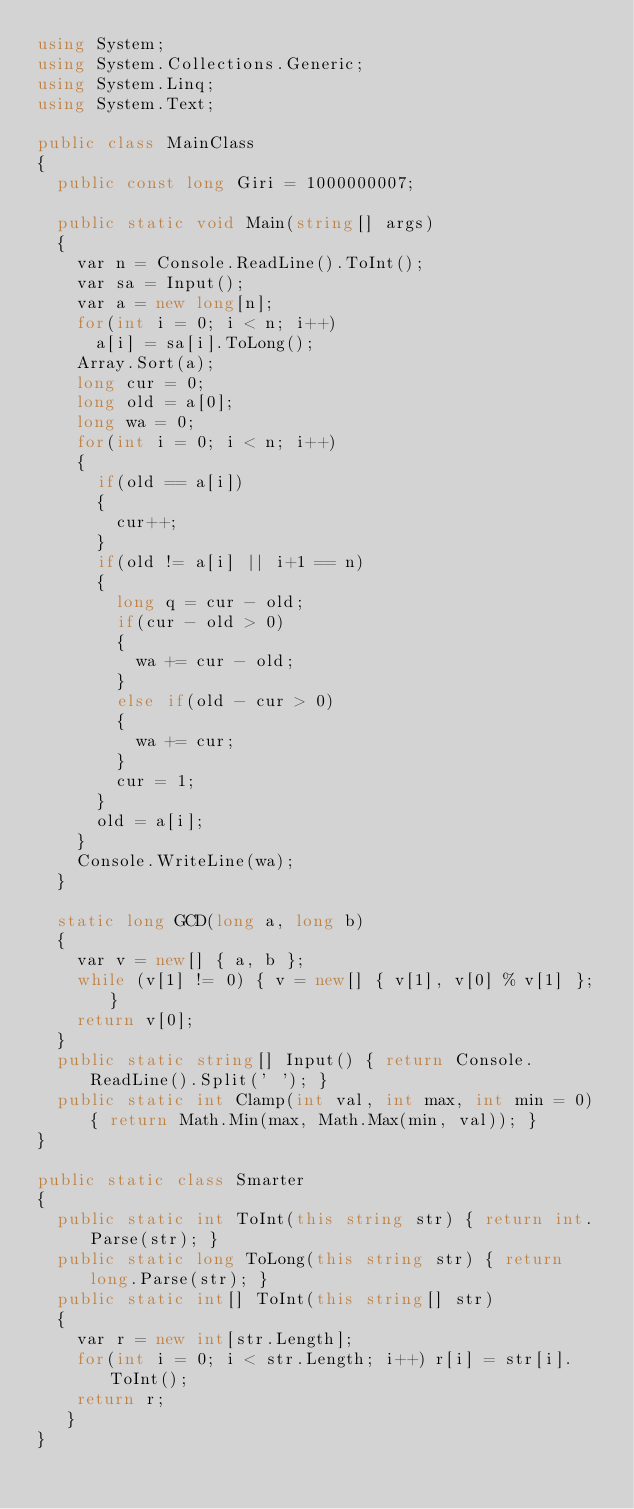Convert code to text. <code><loc_0><loc_0><loc_500><loc_500><_C#_>using System;
using System.Collections.Generic;
using System.Linq;
using System.Text;

public class MainClass
{
	public const long Giri = 1000000007;

	public static void Main(string[] args)
	{
		var n = Console.ReadLine().ToInt();
		var sa = Input();
		var a = new long[n];
		for(int i = 0; i < n; i++)
			a[i] = sa[i].ToLong();
		Array.Sort(a);
		long cur = 0;
		long old = a[0];
		long wa = 0;
		for(int i = 0; i < n; i++)
		{
			if(old == a[i])
			{
				cur++;
			}
			if(old != a[i] || i+1 == n)
			{
				long q = cur - old;
				if(cur - old > 0)
				{
					wa += cur - old;
				}
				else if(old - cur > 0)
				{
					wa += cur;
				}
				cur = 1;
			}
			old = a[i];
		}
		Console.WriteLine(wa);
	}

	static long GCD(long a, long b)
	{
		var v = new[] { a, b };
		while (v[1] != 0) { v = new[] { v[1], v[0] % v[1] }; }
		return v[0];
	}
	public static string[] Input() { return Console.ReadLine().Split(' '); }
	public static int Clamp(int val, int max, int min = 0) { return Math.Min(max, Math.Max(min, val)); }
}

public static class Smarter
{
	public static int ToInt(this string str) { return int.Parse(str); }
	public static long ToLong(this string str) { return long.Parse(str); }
	public static int[] ToInt(this string[] str)
	{
		var r = new int[str.Length];
		for(int i = 0; i < str.Length; i++) r[i] = str[i].ToInt();
		return r;
	 }
}
</code> 